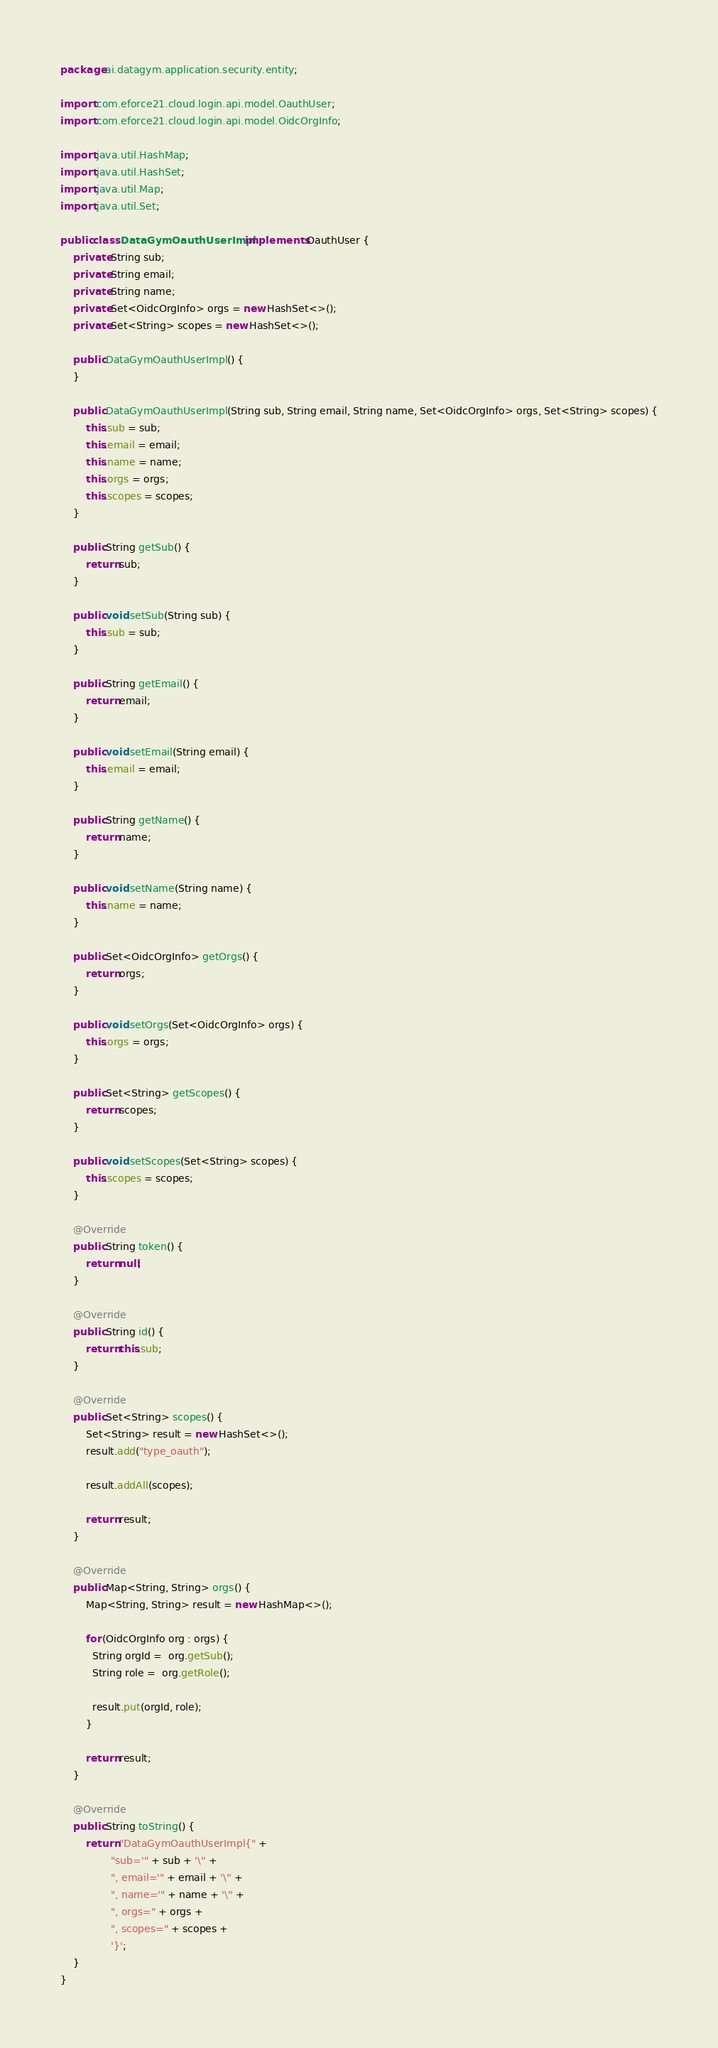<code> <loc_0><loc_0><loc_500><loc_500><_Java_>package ai.datagym.application.security.entity;

import com.eforce21.cloud.login.api.model.OauthUser;
import com.eforce21.cloud.login.api.model.OidcOrgInfo;

import java.util.HashMap;
import java.util.HashSet;
import java.util.Map;
import java.util.Set;

public class DataGymOauthUserImpl implements OauthUser {
    private String sub;
    private String email;
    private String name;
    private Set<OidcOrgInfo> orgs = new HashSet<>();
    private Set<String> scopes = new HashSet<>();

    public DataGymOauthUserImpl() {
    }

    public DataGymOauthUserImpl(String sub, String email, String name, Set<OidcOrgInfo> orgs, Set<String> scopes) {
        this.sub = sub;
        this.email = email;
        this.name = name;
        this.orgs = orgs;
        this.scopes = scopes;
    }

    public String getSub() {
        return sub;
    }

    public void setSub(String sub) {
        this.sub = sub;
    }

    public String getEmail() {
        return email;
    }

    public void setEmail(String email) {
        this.email = email;
    }

    public String getName() {
        return name;
    }

    public void setName(String name) {
        this.name = name;
    }

    public Set<OidcOrgInfo> getOrgs() {
        return orgs;
    }

    public void setOrgs(Set<OidcOrgInfo> orgs) {
        this.orgs = orgs;
    }

    public Set<String> getScopes() {
        return scopes;
    }

    public void setScopes(Set<String> scopes) {
        this.scopes = scopes;
    }

    @Override
    public String token() {
        return null;
    }

    @Override
    public String id() {
        return this.sub;
    }

    @Override
    public Set<String> scopes() {
        Set<String> result = new HashSet<>();
        result.add("type_oauth");

        result.addAll(scopes);

        return result;
    }

    @Override
    public Map<String, String> orgs() {
        Map<String, String> result = new HashMap<>();

        for (OidcOrgInfo org : orgs) {
          String orgId =  org.getSub();
          String role =  org.getRole();

          result.put(orgId, role);
        }

        return result;
    }

    @Override
    public String toString() {
        return "DataGymOauthUserImpl{" +
                "sub='" + sub + '\'' +
                ", email='" + email + '\'' +
                ", name='" + name + '\'' +
                ", orgs=" + orgs +
                ", scopes=" + scopes +
                '}';
    }
}
</code> 